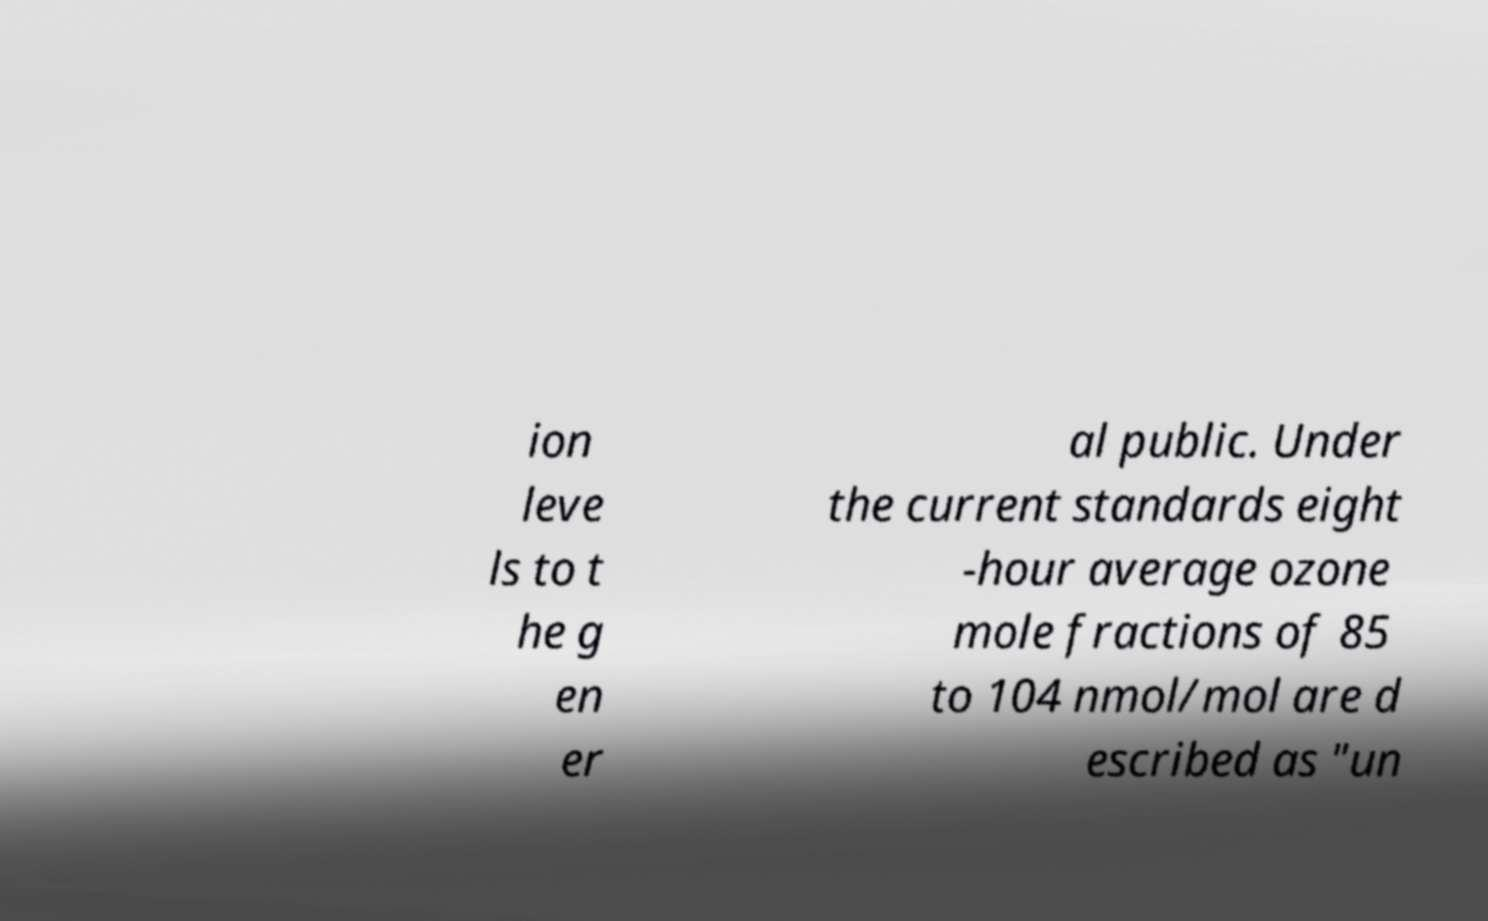There's text embedded in this image that I need extracted. Can you transcribe it verbatim? ion leve ls to t he g en er al public. Under the current standards eight -hour average ozone mole fractions of 85 to 104 nmol/mol are d escribed as "un 